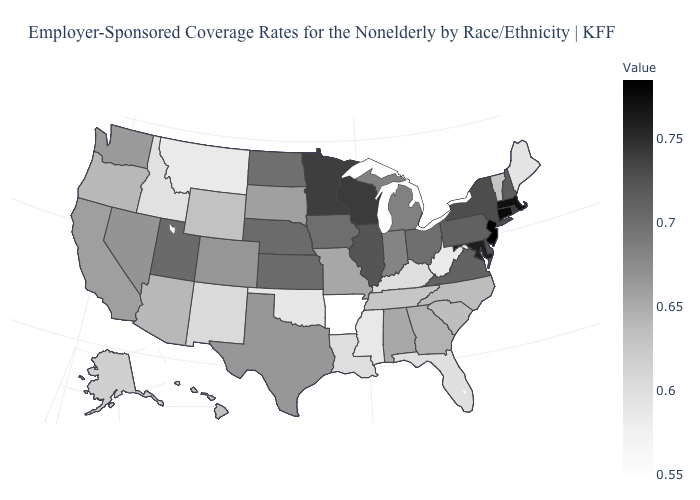Does the map have missing data?
Concise answer only. No. Which states have the lowest value in the South?
Give a very brief answer. Arkansas. Does Nebraska have a higher value than Kentucky?
Concise answer only. Yes. 